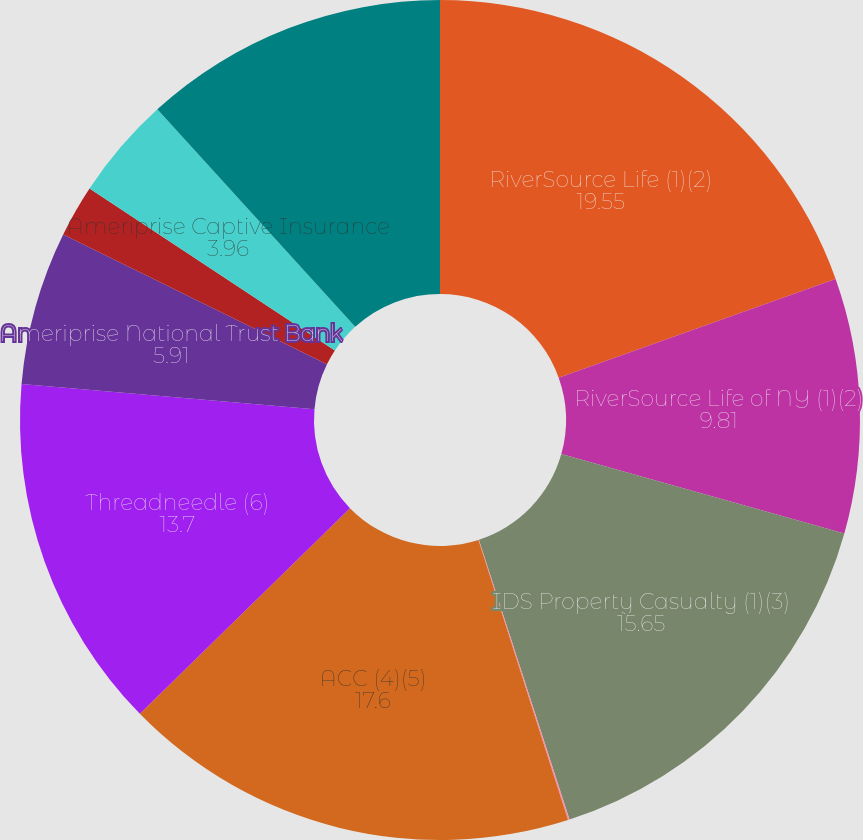Convert chart to OTSL. <chart><loc_0><loc_0><loc_500><loc_500><pie_chart><fcel>RiverSource Life (1)(2)<fcel>RiverSource Life of NY (1)(2)<fcel>IDS Property Casualty (1)(3)<fcel>Ameriprise Insurance Company<fcel>ACC (4)(5)<fcel>Threadneedle (6)<fcel>Ameriprise National Trust Bank<fcel>AFSI (3)(4)<fcel>Ameriprise Captive Insurance<fcel>Ameriprise Trust Company (3)<nl><fcel>19.55%<fcel>9.81%<fcel>15.65%<fcel>0.06%<fcel>17.6%<fcel>13.7%<fcel>5.91%<fcel>2.01%<fcel>3.96%<fcel>11.75%<nl></chart> 